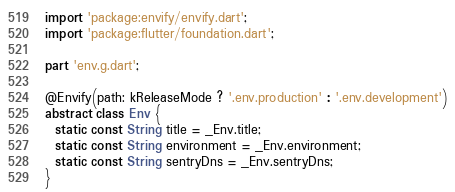Convert code to text. <code><loc_0><loc_0><loc_500><loc_500><_Dart_>import 'package:envify/envify.dart';
import 'package:flutter/foundation.dart';

part 'env.g.dart';

@Envify(path: kReleaseMode ? '.env.production' : '.env.development')
abstract class Env {
  static const String title = _Env.title;
  static const String environment = _Env.environment;
  static const String sentryDns = _Env.sentryDns;
}
</code> 